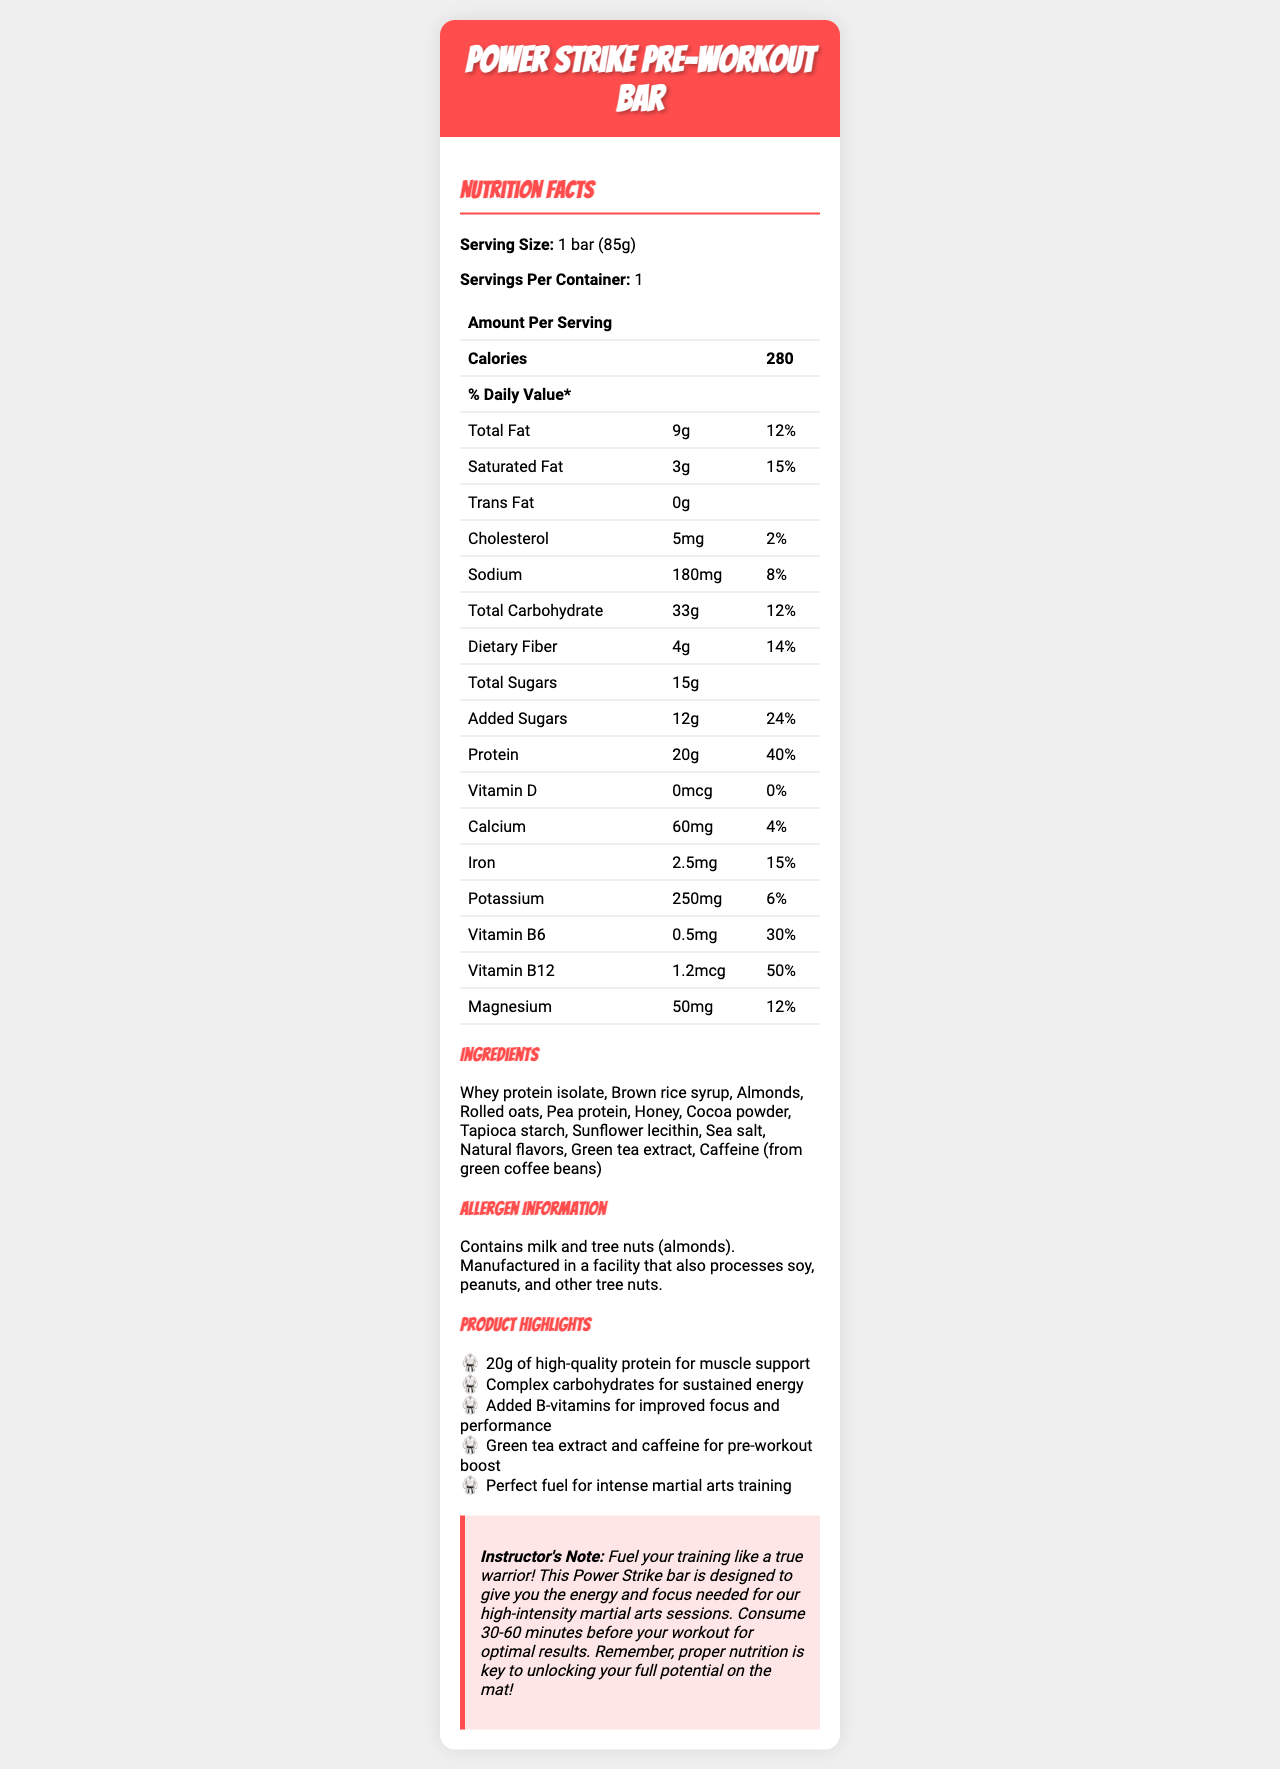what is the serving size of the Power Strike Pre-Workout Bar? The serving size is specified directly under the product name in the nutrition facts label.
Answer: 1 bar (85g) how many calories are in one serving of this energy bar? The number of calories per serving is listed in the first row under "Amount Per Serving".
Answer: 280 what is the amount of protein per serving, and what percentage of the daily value does it represent? The amount of protein and its daily value percentage are listed in the nutrition facts table.
Answer: 20g, 40% which vitamins are included in the Power Strike Pre-Workout Bar and their daily value percentages? The vitamins and their daily values are listed in the nutrition facts table.
Answer: Vitamin D (0%), Vitamin B6 (30%), Vitamin B12 (50%) how much added sugar does the bar contain, and what percentage of the daily value does it represent? The amount of added sugars and their daily value percentage are listed in the nutrition facts table.
Answer: 12g, 24% which of the following ingredients is NOT included in the Power Strike Pre-Workout Bar? A. Almonds B. Peanuts C. Whey protein isolate Almonds and Whey protein isolate are listed in the ingredients section, while peanuts are only mentioned in the allergen info as processed in the facility, not as an ingredient.
Answer: B. Peanuts what is the marketing claim related to the energetic effect of the bar? A. Provides electrolytes B. Sustained energy from complex carbohydrates C. Low-fat content The marketing claims section mentions "Complex carbohydrates for sustained energy".
Answer: B. Sustained energy from complex carbohydrates is the bar suitable for someone with a nut allergy? The allergen info states that the bar contains tree nuts (almonds).
Answer: No summarize the main idea of the document. The summary includes the key points from the document: nutritional content, ingredients, specific benefits, and consumption recommendations for martial arts training.
Answer: The document provides detailed nutritional information about the "Power Strike Pre-Workout Bar," highlighting its high protein content, ingredients, and the benefits of consuming it before intense martial arts workouts. what is the exact amount of caffeine in the bar? The document lists caffeine as an ingredient but does not specify the exact amount.
Answer: Not enough information 